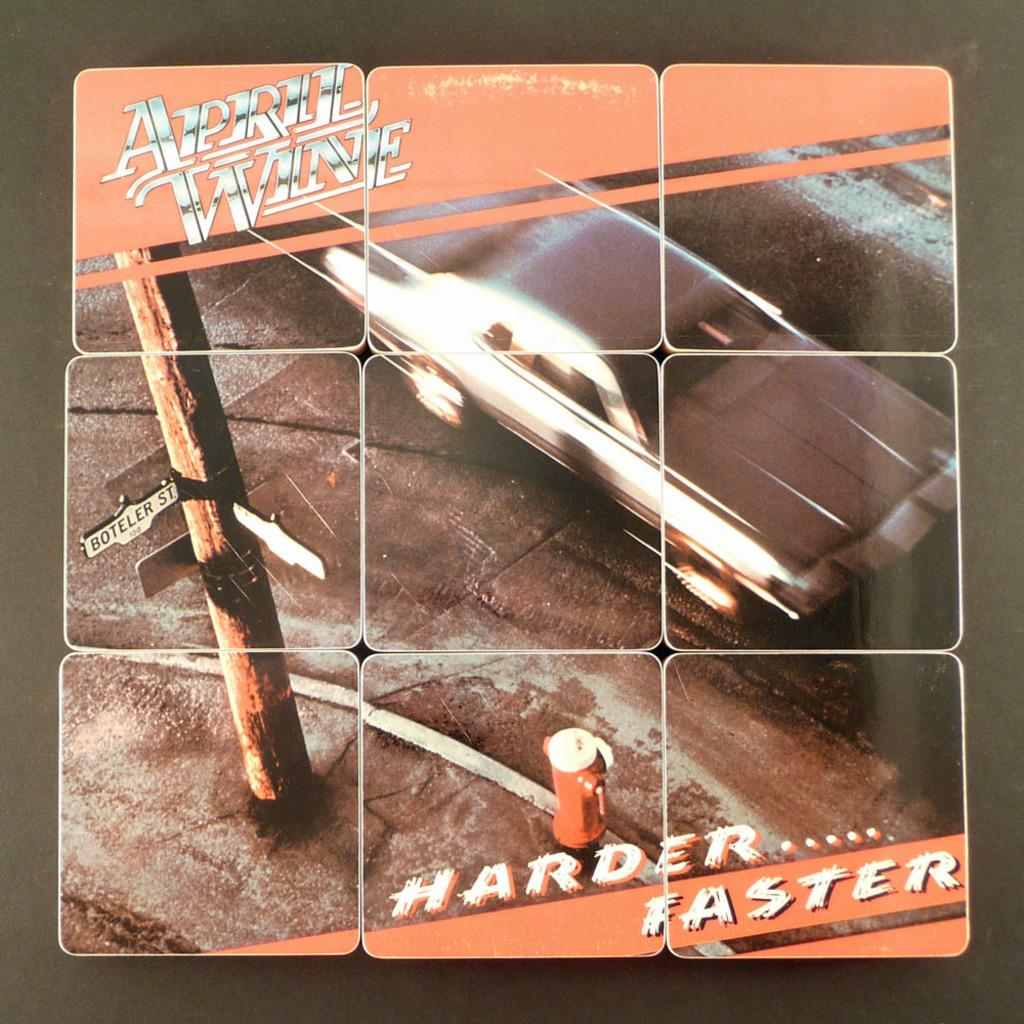<image>
Give a short and clear explanation of the subsequent image. Harder Faster April Wine cover with Boteller Street on the cover. 